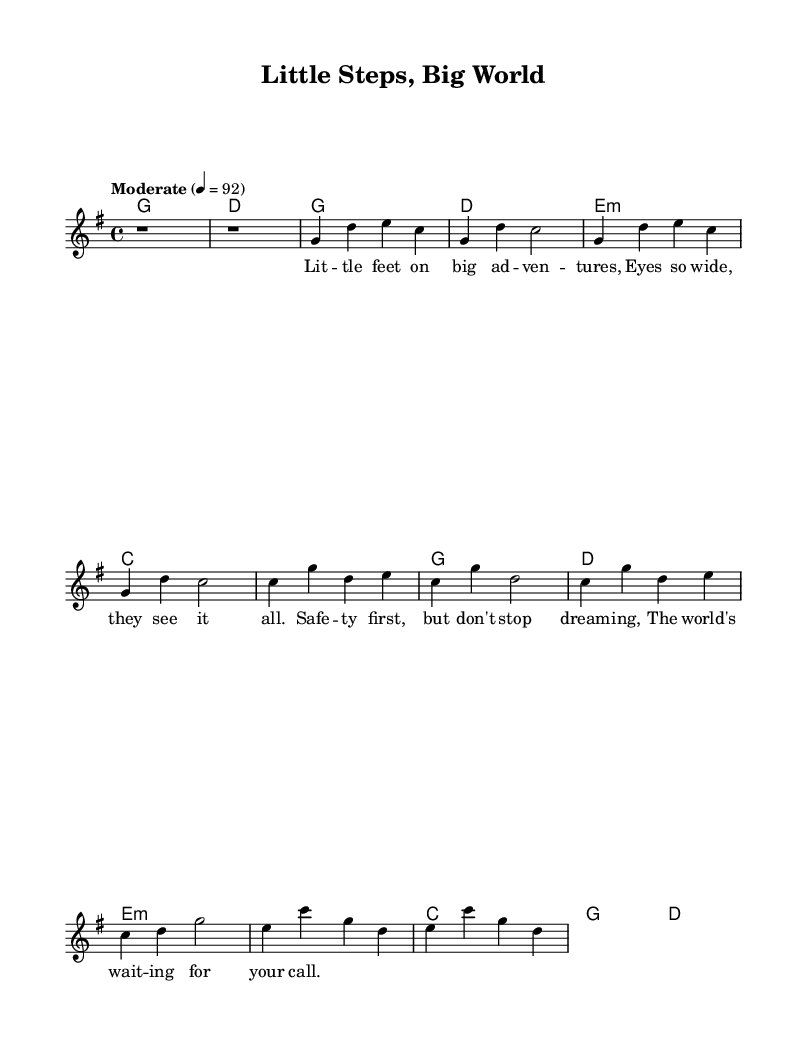What is the key signature of this music? The key signature is G major, which has one sharp (F#).
Answer: G major What is the time signature of this music? The time signature is 4/4, indicating four beats per measure.
Answer: 4/4 What is the tempo marking of this music? The tempo marking indicates a moderate speed of 92 beats per minute.
Answer: Moderate 4 = 92 How many measures are in the verse section? The verse contains two repeated sets of four measures. Therefore, it has eight measures total.
Answer: 8 measures What is the emotional theme explored in the lyrics? The lyrics focus on safety and encouraging dreams, which reflect themes of child psychology.
Answer: Safety and dreaming What chord begins the bridge section? The bridge section starts with an E minor chord, as indicated in the harmonies.
Answer: E minor What is the structure of the song based on the sections? The structure consists of an intro, verse, chorus, and bridge, with the verse and chorus repeated.
Answer: Intro, verse, chorus, bridge 